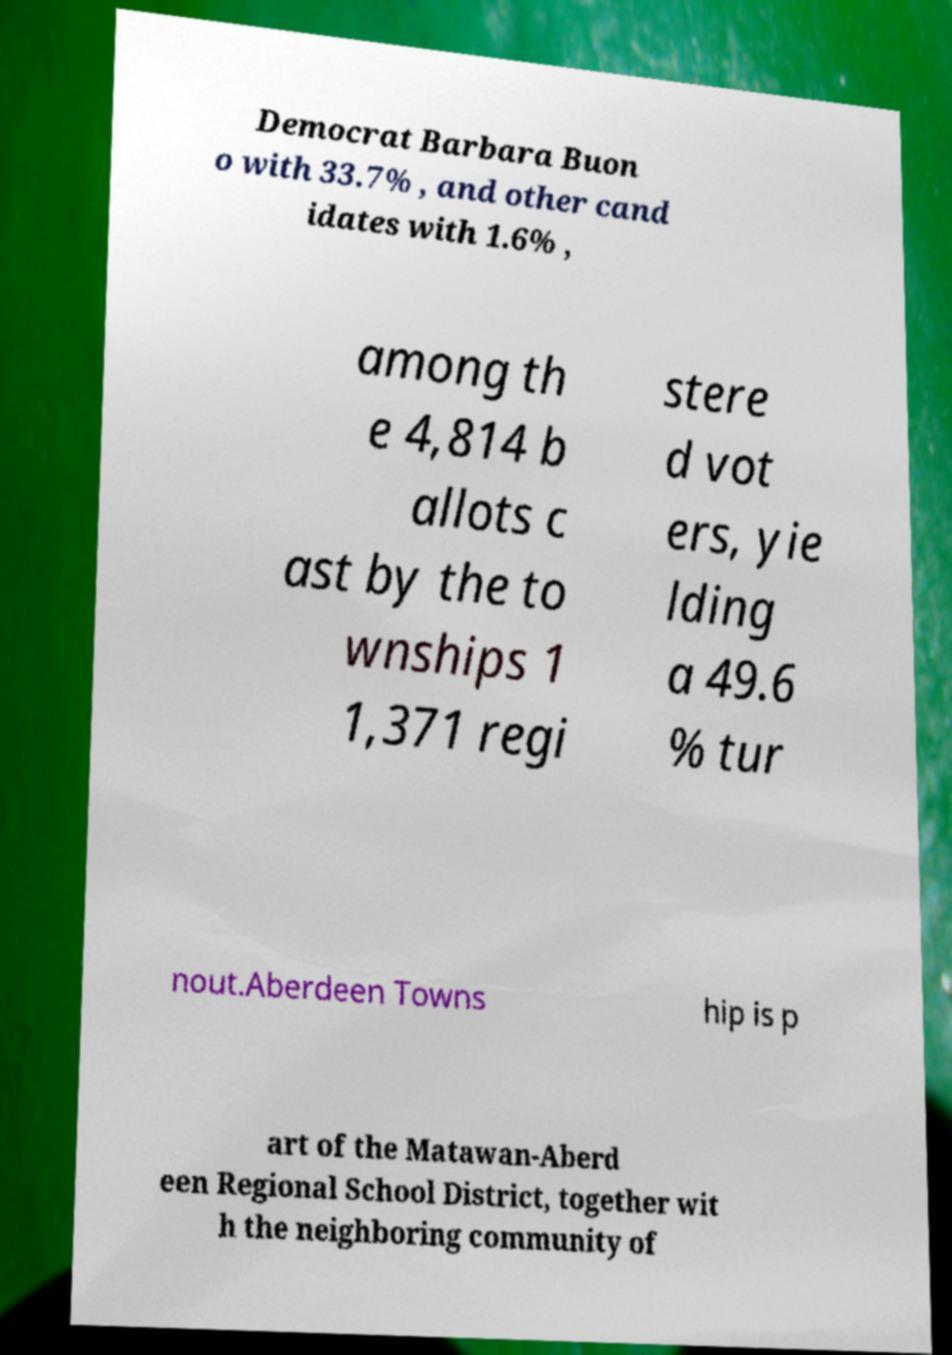What messages or text are displayed in this image? I need them in a readable, typed format. Democrat Barbara Buon o with 33.7% , and other cand idates with 1.6% , among th e 4,814 b allots c ast by the to wnships 1 1,371 regi stere d vot ers, yie lding a 49.6 % tur nout.Aberdeen Towns hip is p art of the Matawan-Aberd een Regional School District, together wit h the neighboring community of 